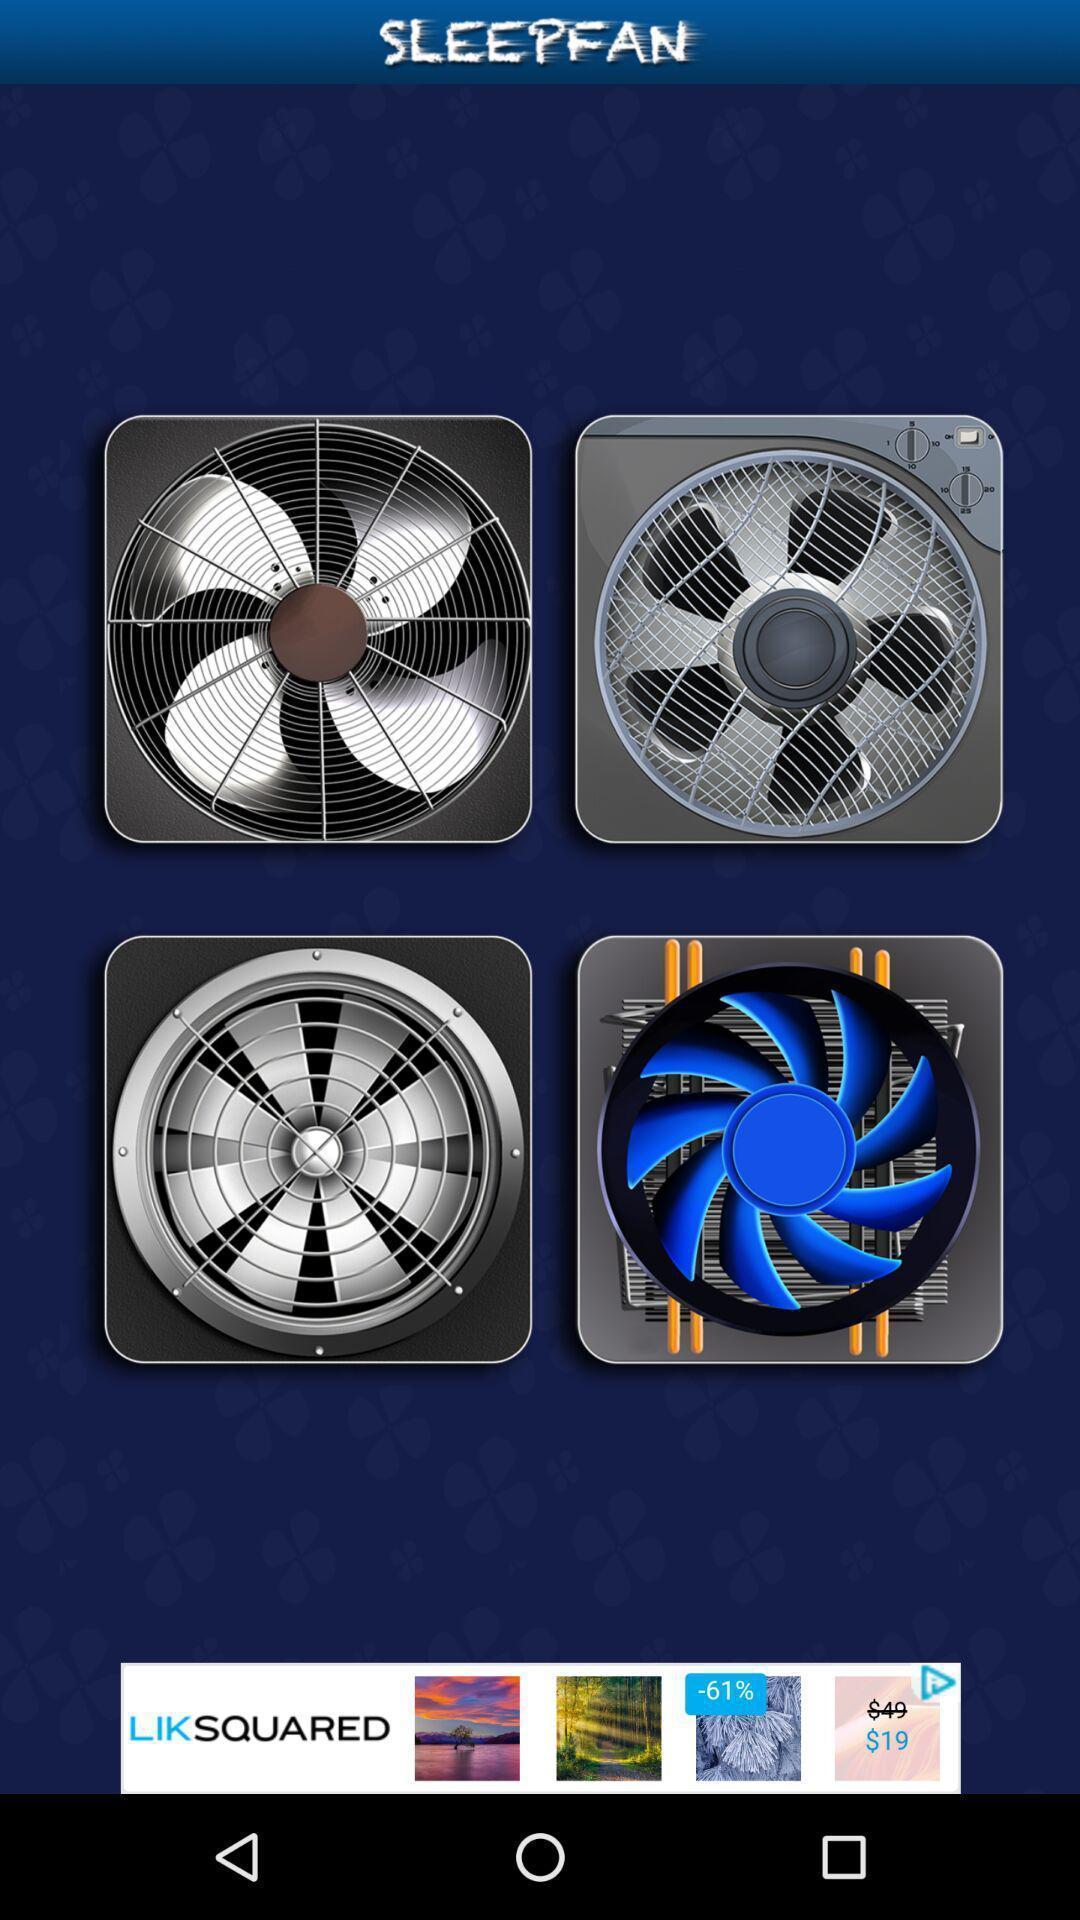What is the overall content of this screenshot? Various exhaust fan images displayed. 